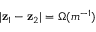<formula> <loc_0><loc_0><loc_500><loc_500>| z _ { 1 } - z _ { 2 } | = \Omega ( m ^ { - 1 } )</formula> 